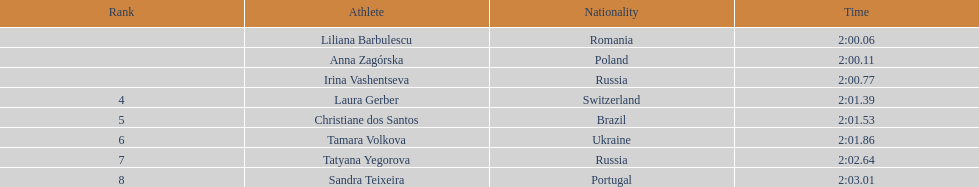The last runner crossed the finish line in 2:03.01. what was the previous time for the 7th runner? 2:02.64. 